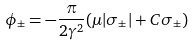Convert formula to latex. <formula><loc_0><loc_0><loc_500><loc_500>\phi _ { \pm } = - \frac { \pi } { 2 \gamma ^ { 2 } } ( \mu | \sigma _ { \pm } | + C \sigma _ { \pm } )</formula> 